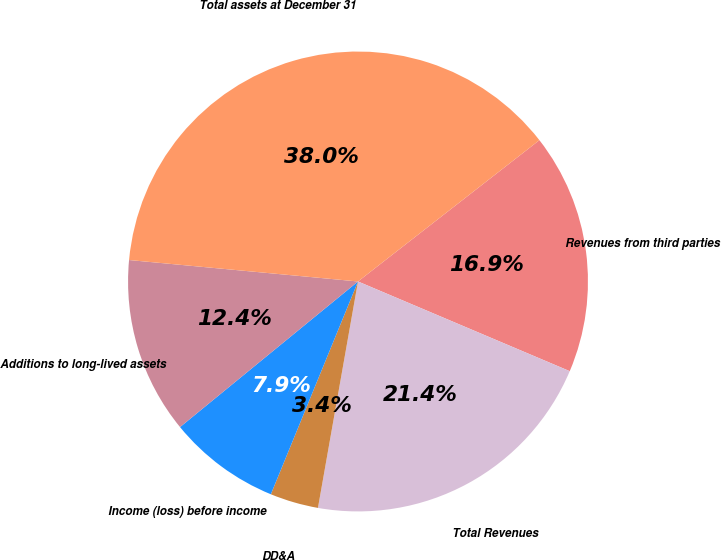Convert chart to OTSL. <chart><loc_0><loc_0><loc_500><loc_500><pie_chart><fcel>Revenues from third parties<fcel>Total Revenues<fcel>DD&A<fcel>Income (loss) before income<fcel>Additions to long-lived assets<fcel>Total assets at December 31<nl><fcel>16.91%<fcel>21.41%<fcel>3.4%<fcel>7.9%<fcel>12.4%<fcel>37.98%<nl></chart> 